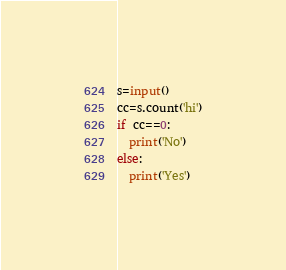Convert code to text. <code><loc_0><loc_0><loc_500><loc_500><_Python_>s=input()
cc=s.count('hi')
if cc==0:
  print('No')
else:
  print('Yes')
</code> 